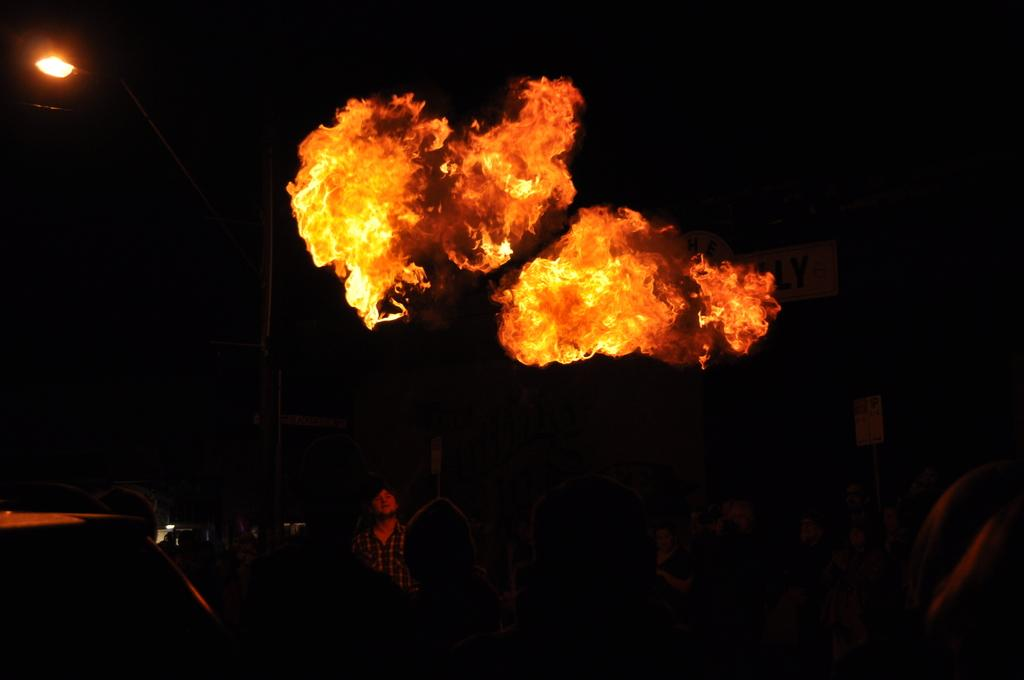What is the main subject in the middle of the image? There is fire in the middle of the image. Can you describe the person's position in relation to the fire? There is a person below the fire. What can be seen in the background of the image? There is a light in the background. How would you describe the overall color of the background? The background is dark in color. Where is the drain located in the image? There is no drain present in the image. Can you describe the nest in the image? There is no nest present in the image. 